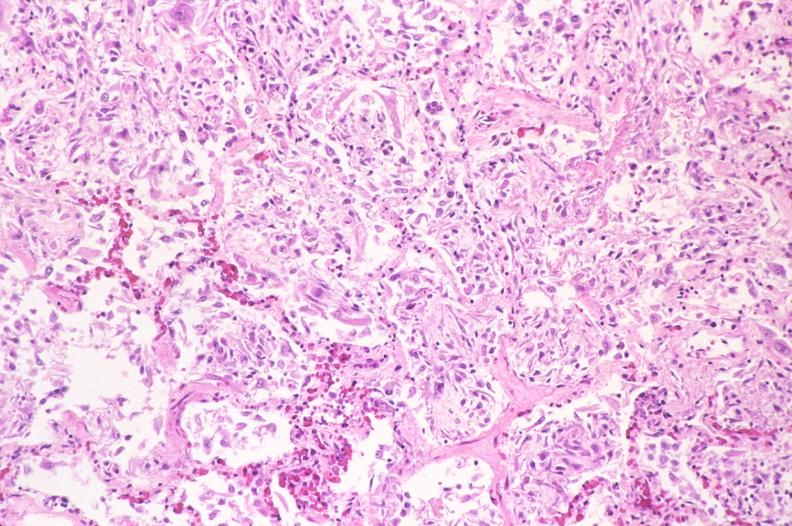s respiratory present?
Answer the question using a single word or phrase. Yes 